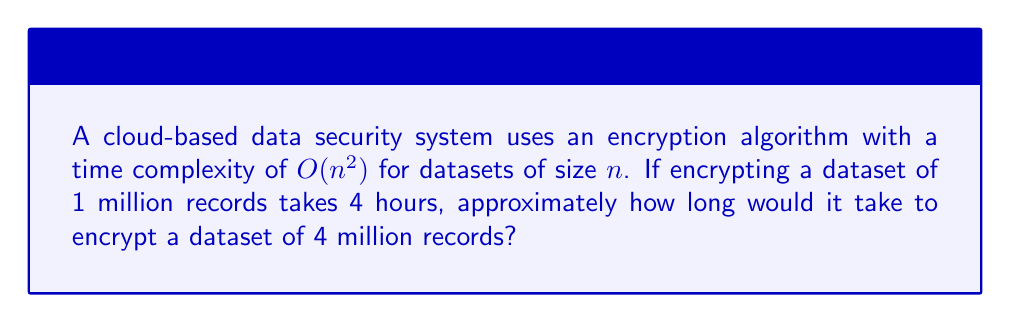Can you solve this math problem? To solve this problem, we need to understand the relationship between the input size and the time complexity:

1. Given information:
   - Time complexity: $O(n^2)$
   - Dataset 1: $n_1 = 1$ million records, $t_1 = 4$ hours
   - Dataset 2: $n_2 = 4$ million records, $t_2 = ?$ hours

2. For $O(n^2)$ complexity, the time increases quadratically with the input size:
   $$\frac{t_2}{t_1} = \left(\frac{n_2}{n_1}\right)^2$$

3. Substituting the known values:
   $$\frac{t_2}{4} = \left(\frac{4}{1}\right)^2 = 16$$

4. Solving for $t_2$:
   $$t_2 = 4 \times 16 = 64$$

Therefore, it would take approximately 64 hours to encrypt the dataset of 4 million records.
Answer: 64 hours 